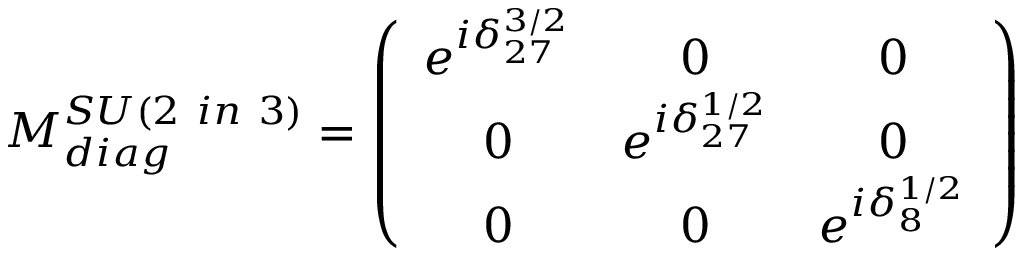<formula> <loc_0><loc_0><loc_500><loc_500>M _ { d i a g } ^ { S U ( 2 i n 3 ) } = \left ( \begin{array} { c c c } { { e ^ { i \delta _ { 2 7 } ^ { 3 / 2 } } } } & { 0 } & { 0 } \\ { 0 } & { { e ^ { i \delta _ { 2 7 } ^ { 1 / 2 } } } } & { 0 } \\ { 0 } & { 0 } & { { e ^ { i \delta _ { 8 } ^ { 1 / 2 } } } } \end{array} \right )</formula> 